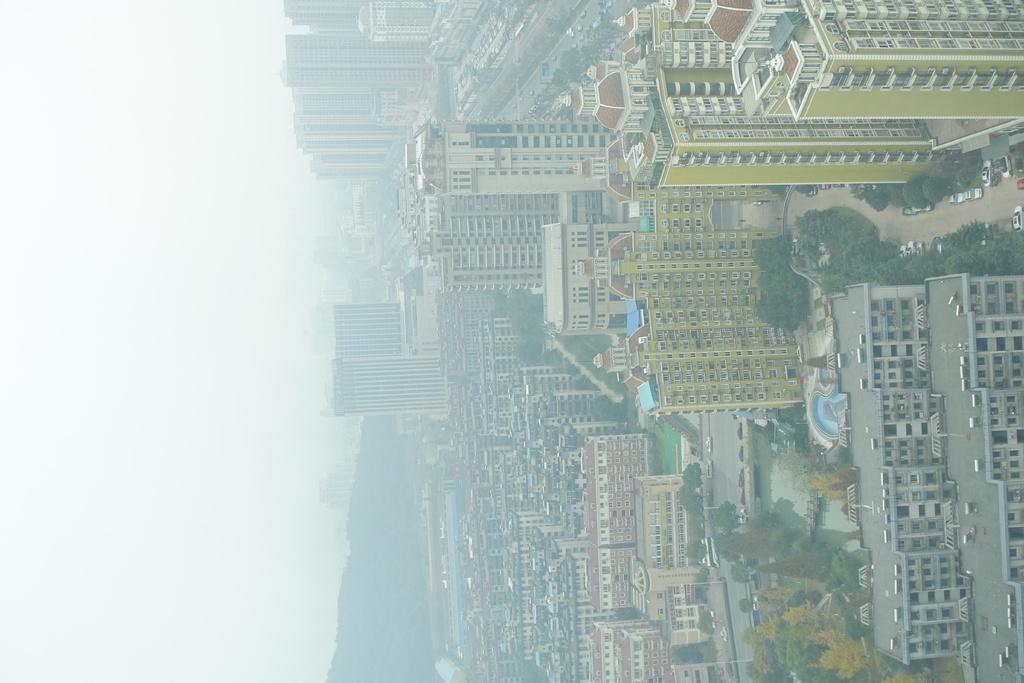What type of structures can be seen in the image? There are buildings in the image. What else can be seen on the ground in the image? There are vehicles on the road in the image. What type of vegetation is visible in the image? There are trees visible in the image. What is visible above the ground in the image? The sky is visible in the image. Where are the friends playing with a gun in the image? There are no friends or guns present in the image. What type of spot is visible on the buildings in the image? There are no spots visible on the buildings in the image. 